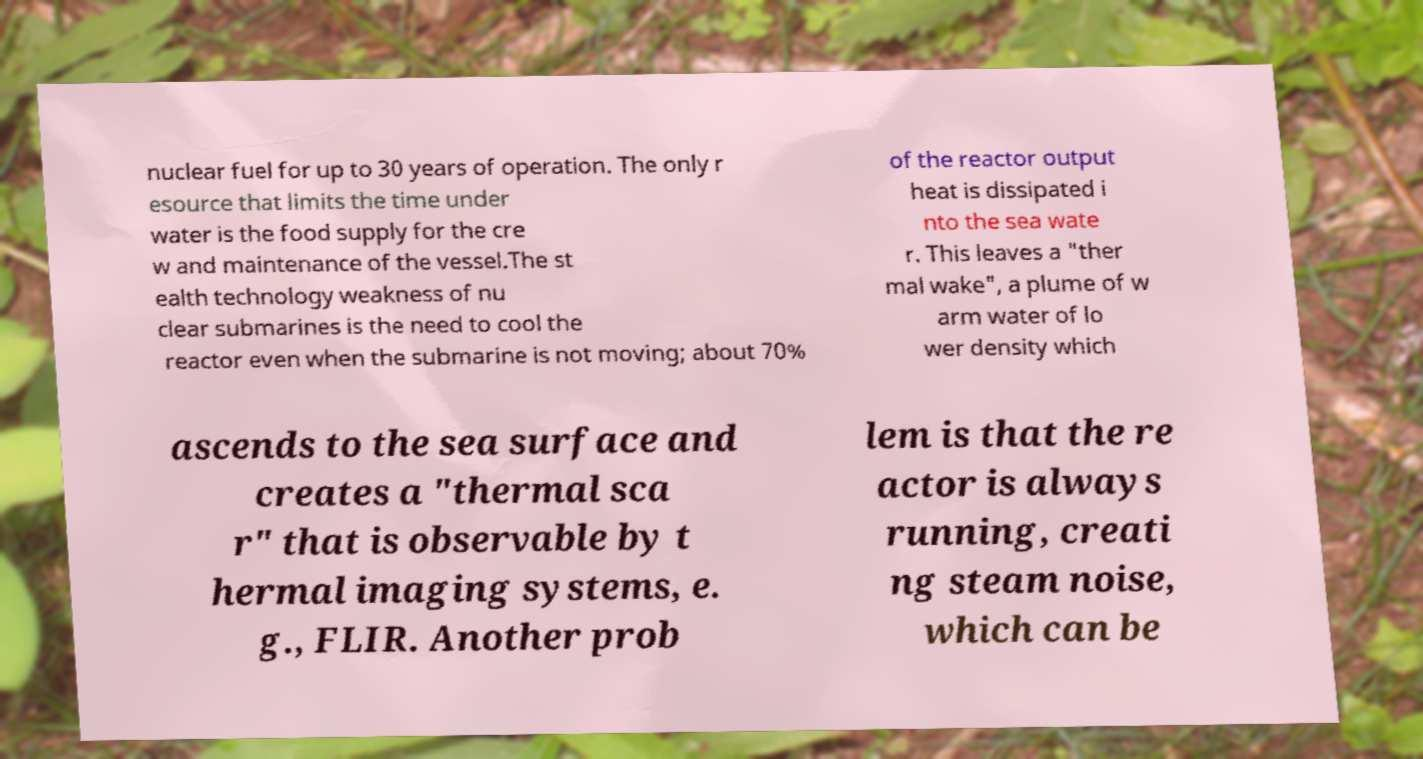For documentation purposes, I need the text within this image transcribed. Could you provide that? nuclear fuel for up to 30 years of operation. The only r esource that limits the time under water is the food supply for the cre w and maintenance of the vessel.The st ealth technology weakness of nu clear submarines is the need to cool the reactor even when the submarine is not moving; about 70% of the reactor output heat is dissipated i nto the sea wate r. This leaves a "ther mal wake", a plume of w arm water of lo wer density which ascends to the sea surface and creates a "thermal sca r" that is observable by t hermal imaging systems, e. g., FLIR. Another prob lem is that the re actor is always running, creati ng steam noise, which can be 